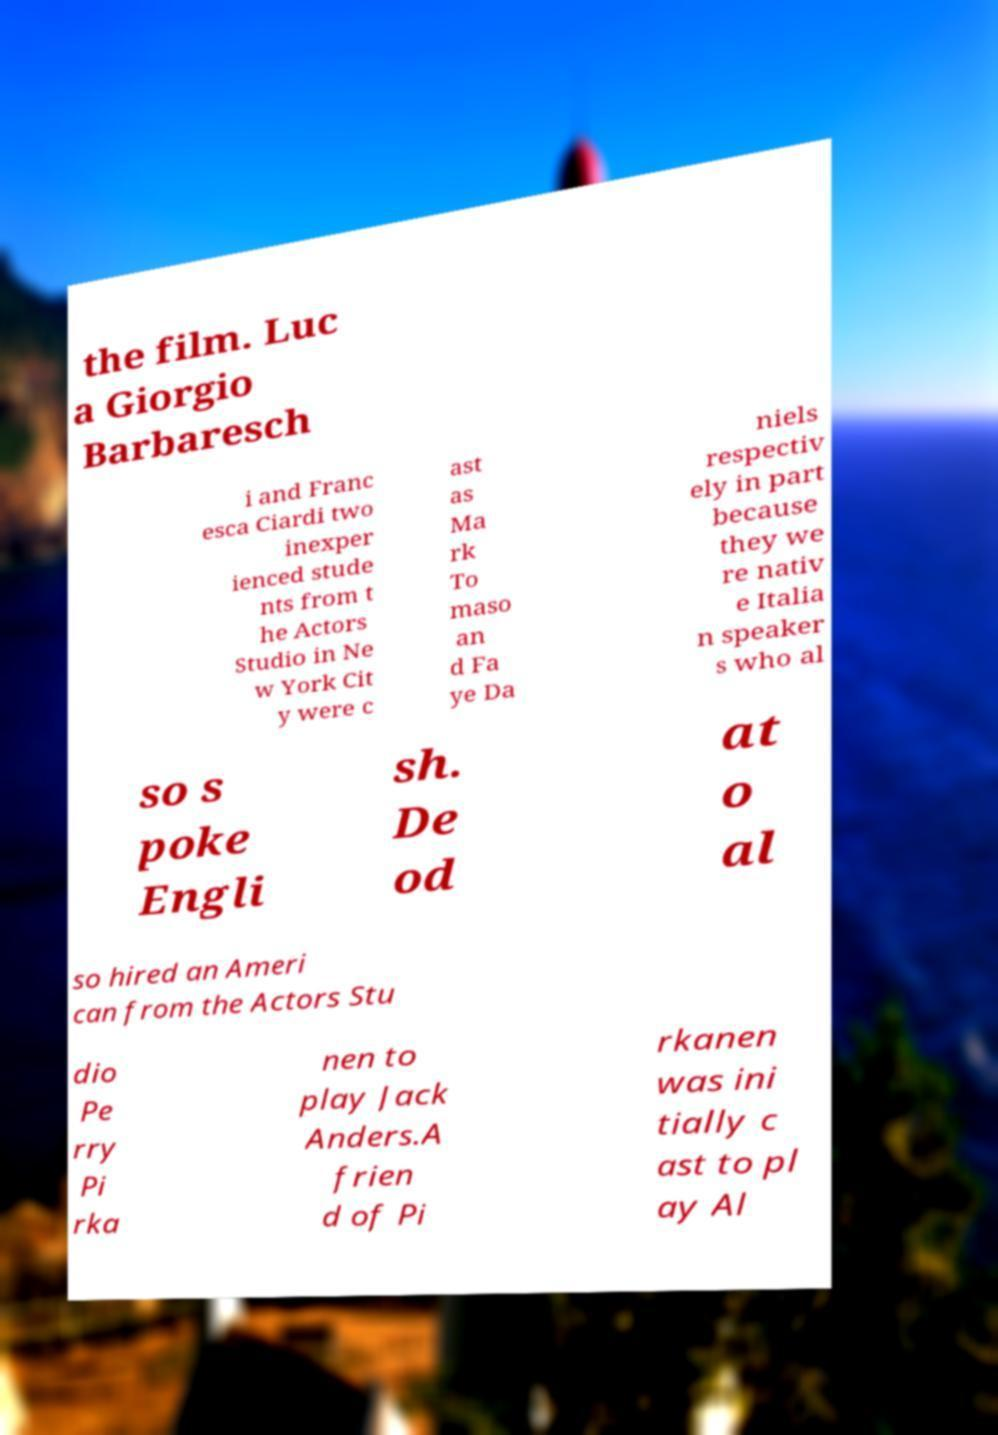I need the written content from this picture converted into text. Can you do that? the film. Luc a Giorgio Barbaresch i and Franc esca Ciardi two inexper ienced stude nts from t he Actors Studio in Ne w York Cit y were c ast as Ma rk To maso an d Fa ye Da niels respectiv ely in part because they we re nativ e Italia n speaker s who al so s poke Engli sh. De od at o al so hired an Ameri can from the Actors Stu dio Pe rry Pi rka nen to play Jack Anders.A frien d of Pi rkanen was ini tially c ast to pl ay Al 